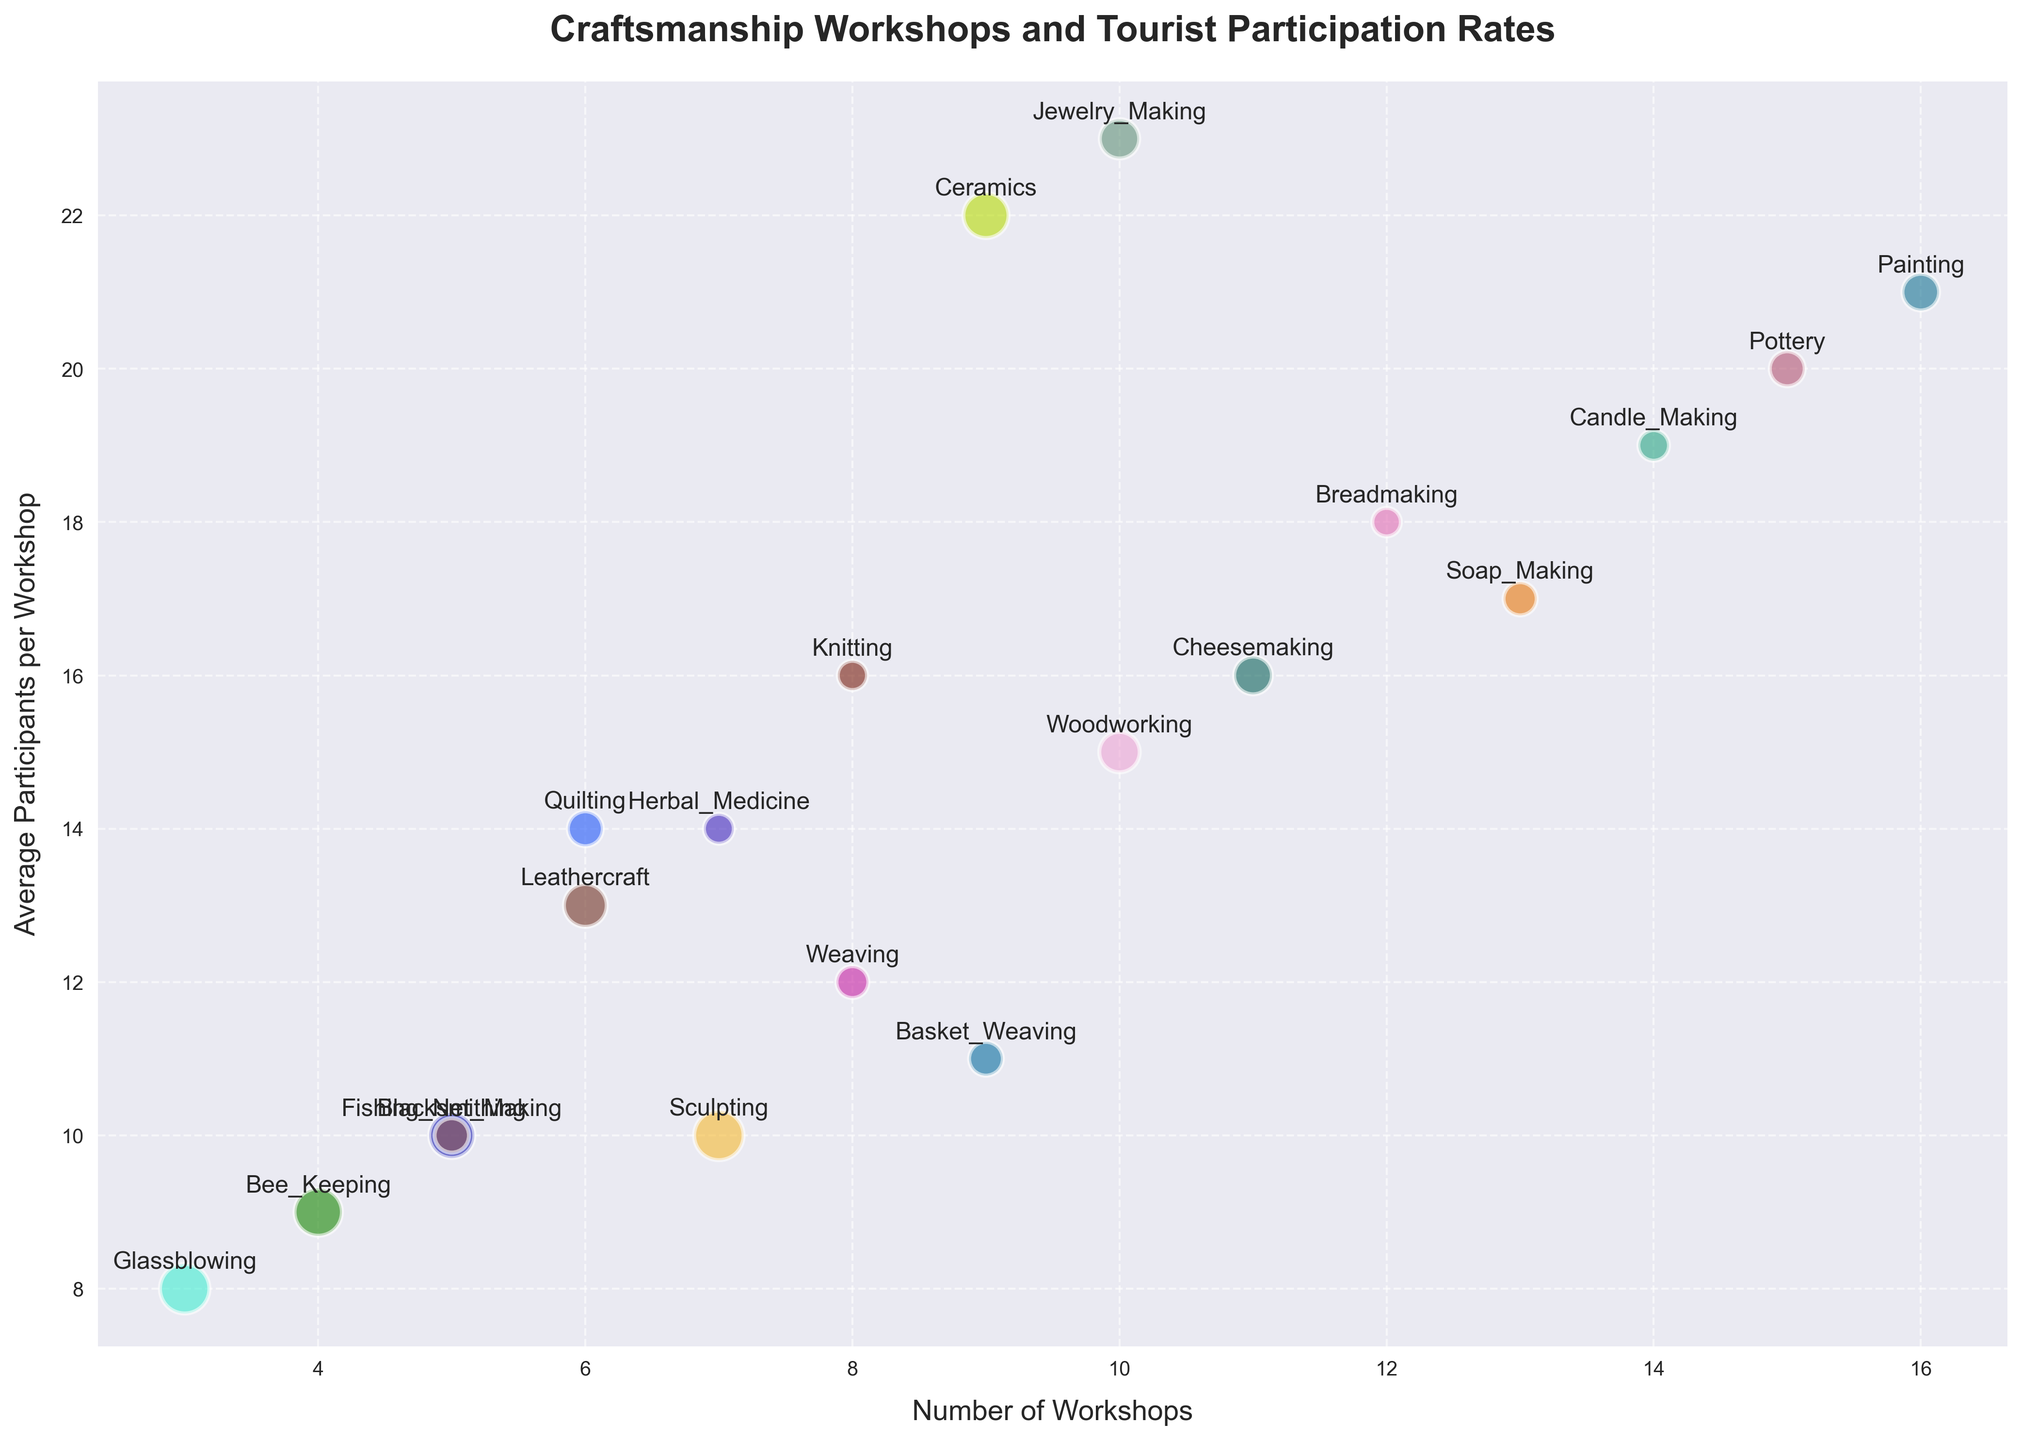How many craft types have more than 10 workshops? First, check the figure for the number of workshops per craft type. Then count the bubbles representing craft types with the number of workshops greater than 10. Crafts with more than 10 workshops are Pottery, Breadmaking, Soap_Making, Candle_Making, and Painting.
Answer: 5 Which craft type engages the highest average number of participants? Observe the vertical axis for average participants per workshop and find the highest value. The highest bubble on the vertical axis represents Painting with 21 average participants.
Answer: Painting What is the total number of workshops for Blacksmithing and Sculpting? Locate the bubbles for Blacksmithing and Sculpting on the horizontal axis. Blacksmithing has 5 workshops, and Sculpting has 7 workshops. Sum these values: 5 + 7.
Answer: 12 Which craft type has the highest profit per participant? Identify the bubble with the largest size since bubble size corresponds to profit per participant. The largest bubble represents Glassblowing, with 60 profit per participant.
Answer: Glassblowing Compare the average number of participants per workshop between Pottery and Candle_Making. Which one is higher? Find and compare the vertical positions of bubbles for Pottery and Candle_Making. Pottery has 20 average participants, and Candle_Making has 19 average participants. Pottery's value is higher.
Answer: Pottery What is the sum of the average participants for Leathercraft, Candle_Making, and Bee_Keeping? Locate the bubbles for Leathercraft, Candle_Making, and Bee_Keeping on the vertical axis. They have 13, 19, and 9 average participants, respectively. Sum these values: 13 + 19 + 9.
Answer: 41 Which craft type has a lower average number of participants, Woodworking or Weaving? Compare the vertical positions of bubbles for Woodworking and Weaving. Woodworking has 15 average participants, while Weaving has 12 average participants. Weaving's value is lower.
Answer: Weaving What is the difference in profit per participant between Jewelry_Making and Knitting? Compare the bubble sizes for Jewelry_Making and Knitting. Jewelry_Making has a profit of 38 per participant, and Knitting has 21 per participant. The difference is 38 - 21.
Answer: 17 